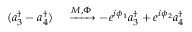<formula> <loc_0><loc_0><loc_500><loc_500>\begin{array} { r l } { ( a _ { 3 } ^ { \dagger } - a _ { 4 } ^ { \dagger } ) } & \xrightarrow { M , \Phi } - e ^ { i \phi _ { 1 } } a _ { 3 } ^ { \dagger } + e ^ { i \phi _ { 2 } } a _ { 4 } ^ { \dagger } } \end{array}</formula> 